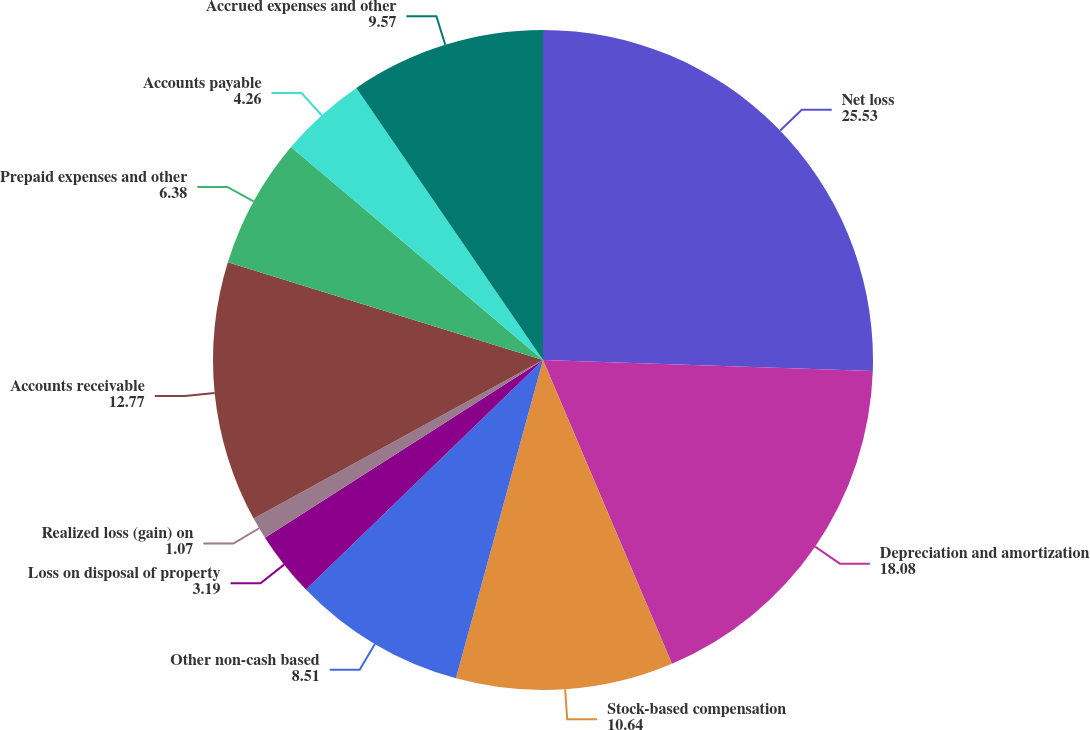<chart> <loc_0><loc_0><loc_500><loc_500><pie_chart><fcel>Net loss<fcel>Depreciation and amortization<fcel>Stock-based compensation<fcel>Other non-cash based<fcel>Loss on disposal of property<fcel>Realized loss (gain) on<fcel>Accounts receivable<fcel>Prepaid expenses and other<fcel>Accounts payable<fcel>Accrued expenses and other<nl><fcel>25.53%<fcel>18.08%<fcel>10.64%<fcel>8.51%<fcel>3.19%<fcel>1.07%<fcel>12.77%<fcel>6.38%<fcel>4.26%<fcel>9.57%<nl></chart> 